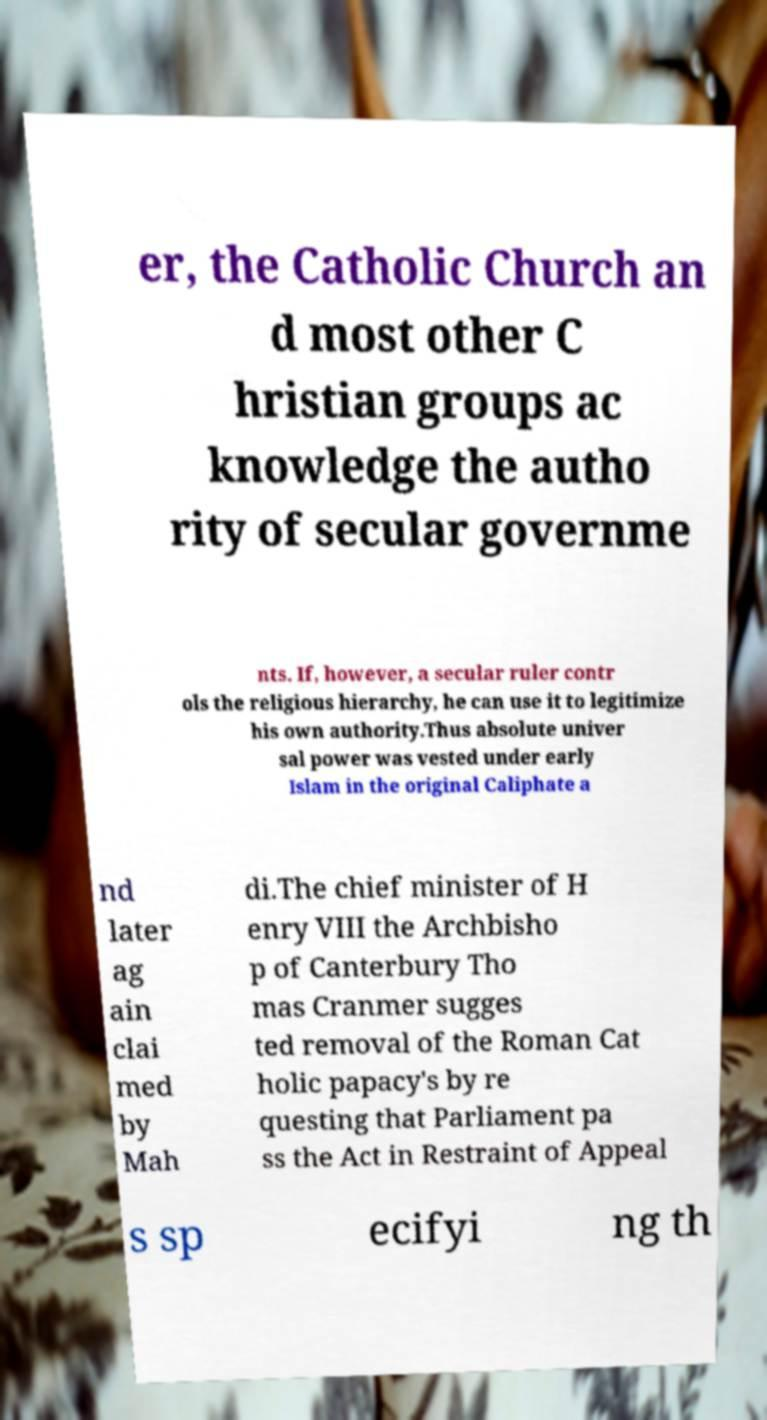Please identify and transcribe the text found in this image. er, the Catholic Church an d most other C hristian groups ac knowledge the autho rity of secular governme nts. If, however, a secular ruler contr ols the religious hierarchy, he can use it to legitimize his own authority.Thus absolute univer sal power was vested under early Islam in the original Caliphate a nd later ag ain clai med by Mah di.The chief minister of H enry VIII the Archbisho p of Canterbury Tho mas Cranmer sugges ted removal of the Roman Cat holic papacy's by re questing that Parliament pa ss the Act in Restraint of Appeal s sp ecifyi ng th 